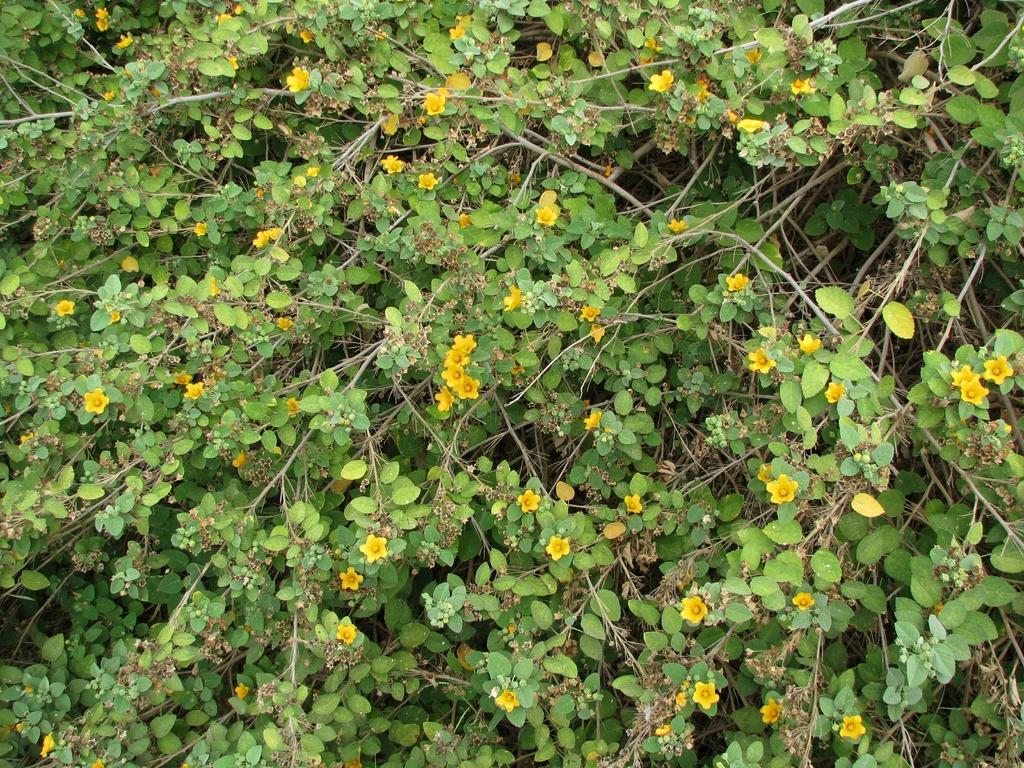What type of living organisms are present in the image? There are plants in the image. What specific features can be observed on the plants? The plants have flowers, leaves, and stems. What type of rhythm can be heard coming from the plants in the image? There is no rhythm present in the image, as plants do not produce sound. 